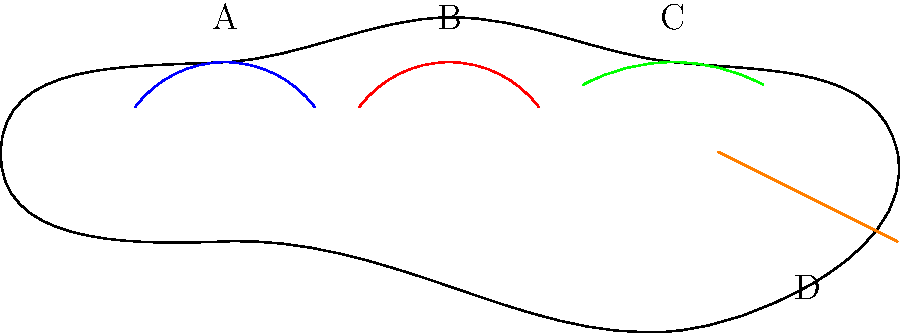In the illustrated diagram of a horse, identify the muscle group labeled 'B', which is crucial for the horse's movement in dressage and directly affected by saddle fit. To identify the muscle group labeled 'B' in the diagram, let's analyze the horse's anatomy step-by-step:

1. The diagram shows a side view of a horse with four labeled muscle groups: A, B, C, and D.

2. Group A (blue) represents the neck muscles, which are important for head carriage and balance but are not directly affected by saddle fit.

3. Group B (red) is located just behind the horse's withers and extends down to the front leg. This area corresponds to the shoulder muscles, specifically the trapezius and rhomboideus.

4. Group C (green) represents the back muscles, which are crucial for carrying the rider but are located further back than the area in question.

5. Group D (orange) shows the hindquarters, which provide power but are not directly under the saddle area.

6. The shoulder muscles (B) are particularly important in dressage as they allow for freedom of movement in the front legs and contribute to the horse's ability to collect and extend its gaits.

7. Saddle fit directly impacts the shoulder muscles. An ill-fitting saddle can restrict the movement of these muscles, affecting the horse's performance in dressage.

Given this analysis, the muscle group labeled 'B' that is crucial for dressage movement and directly affected by saddle fit is the shoulder muscle group.
Answer: Shoulder muscles 